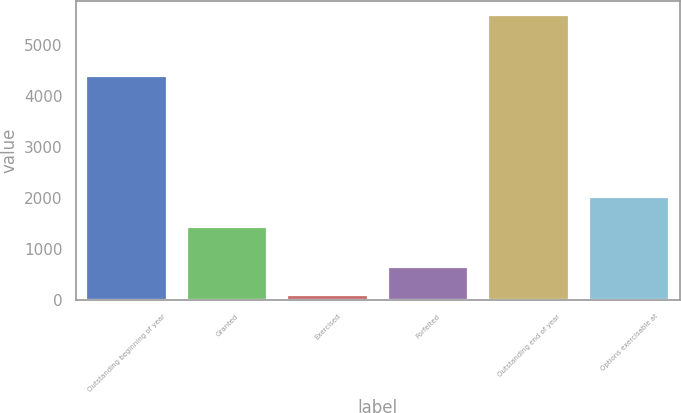Convert chart to OTSL. <chart><loc_0><loc_0><loc_500><loc_500><bar_chart><fcel>Outstanding beginning of year<fcel>Granted<fcel>Exercised<fcel>Forfeited<fcel>Outstanding end of year<fcel>Options exercisable at<nl><fcel>4400<fcel>1427<fcel>93<fcel>642.6<fcel>5589<fcel>2028<nl></chart> 